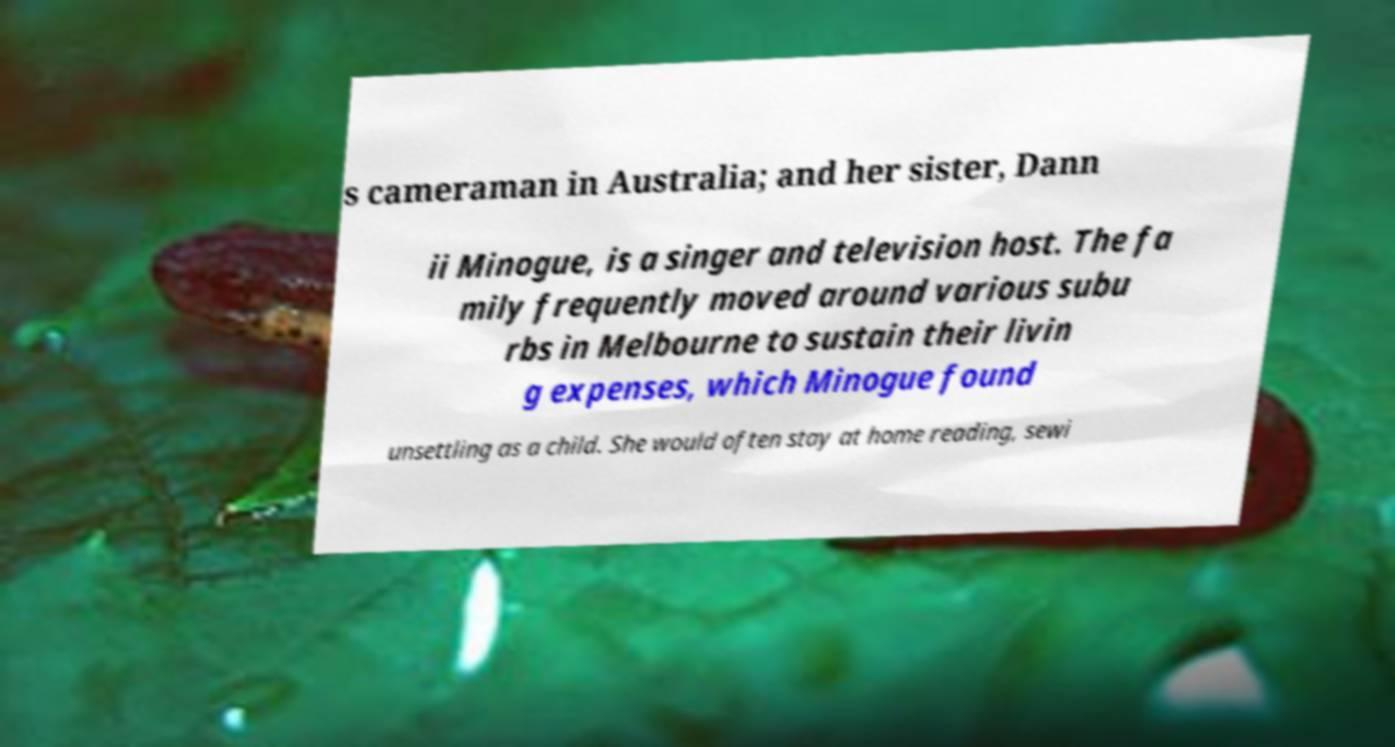Please identify and transcribe the text found in this image. s cameraman in Australia; and her sister, Dann ii Minogue, is a singer and television host. The fa mily frequently moved around various subu rbs in Melbourne to sustain their livin g expenses, which Minogue found unsettling as a child. She would often stay at home reading, sewi 